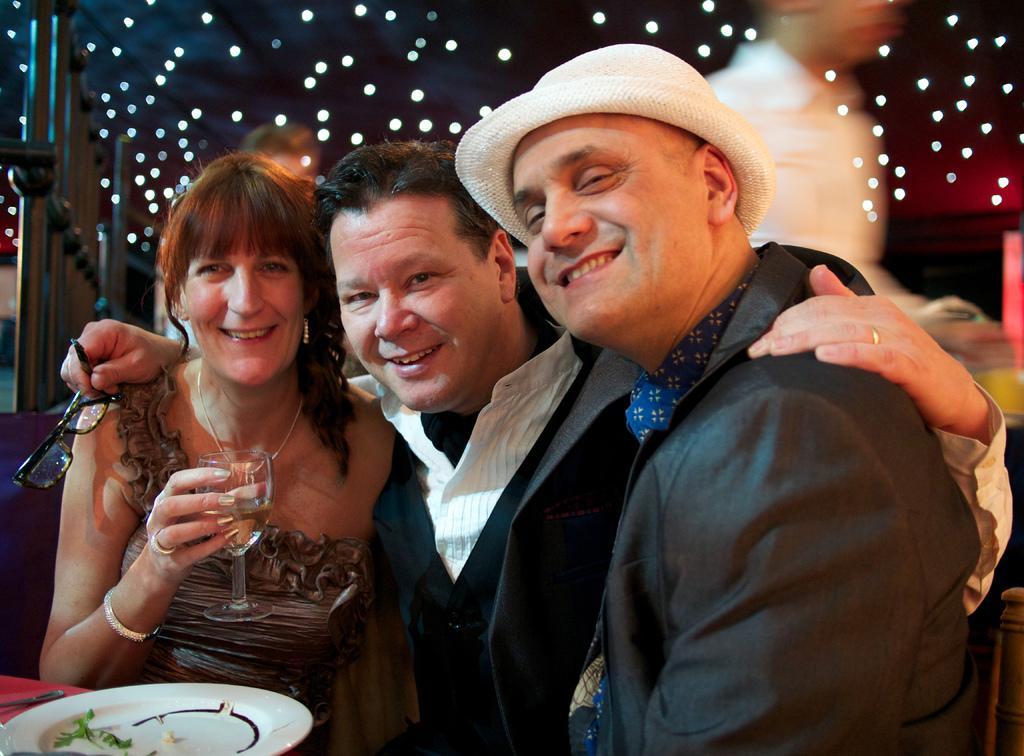In one or two sentences, can you explain what this image depicts? In this image I can see three persons. The person in front wearing black blazer, and the person in the middle wearing black and white dress and the person at left wearing brown color dress and holding a glass, in front I can see a plate in white color, background I can see few lights. 